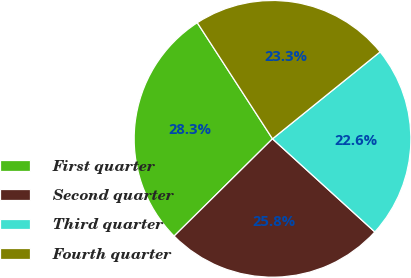Convert chart to OTSL. <chart><loc_0><loc_0><loc_500><loc_500><pie_chart><fcel>First quarter<fcel>Second quarter<fcel>Third quarter<fcel>Fourth quarter<nl><fcel>28.26%<fcel>25.84%<fcel>22.57%<fcel>23.33%<nl></chart> 